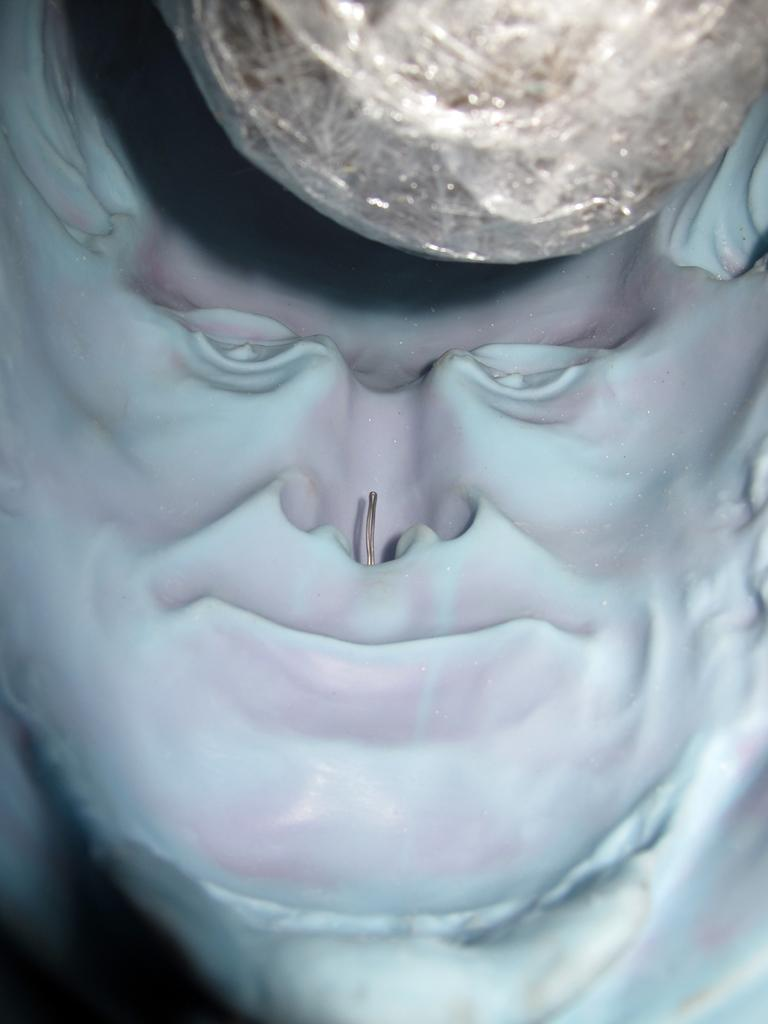What is the main subject of the image? There is a sculpture of a person's face in the image. Can you describe the sculpture in more detail? The sculpture is a representation of a person's face. What material might the sculpture be made of? The material of the sculpture is not specified in the image, so it cannot be determined. What type of spark can be seen coming from the chair in the image? There is no chair present in the image, and therefore no spark can be observed. 